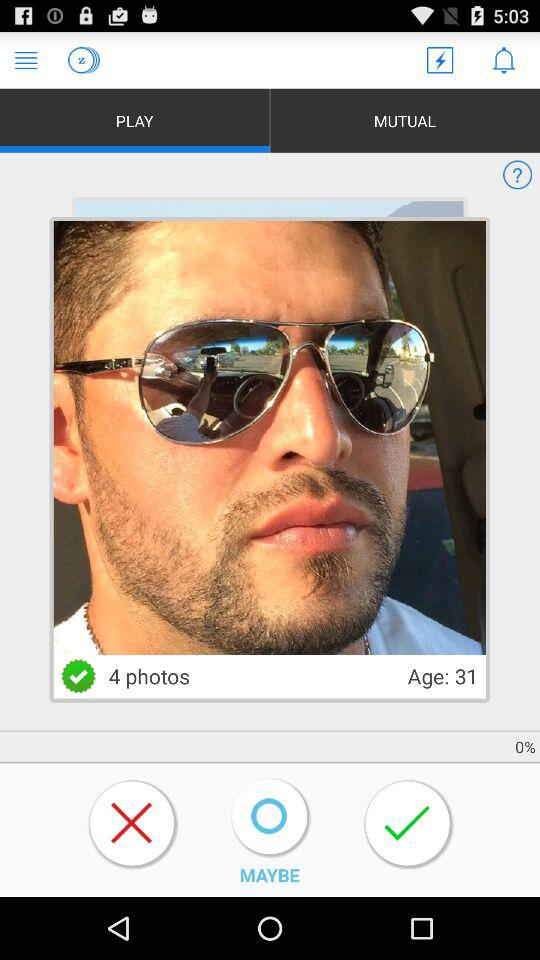How many photos are there? There are 4 photos. 